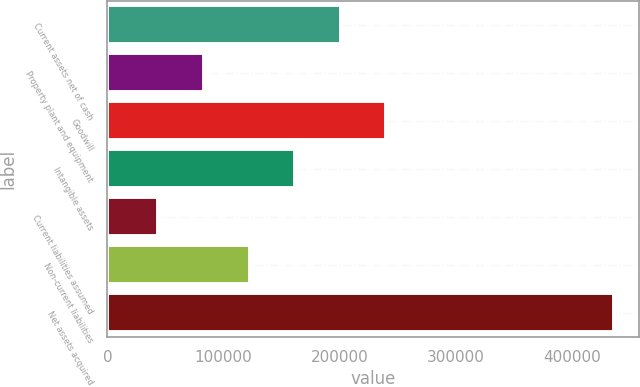Convert chart. <chart><loc_0><loc_0><loc_500><loc_500><bar_chart><fcel>Current assets net of cash<fcel>Property plant and equipment<fcel>Goodwill<fcel>Intangible assets<fcel>Current liabilities assumed<fcel>Non-current liabilities<fcel>Net assets acquired<nl><fcel>200650<fcel>83113.7<fcel>239828<fcel>161471<fcel>43935<fcel>122292<fcel>435722<nl></chart> 